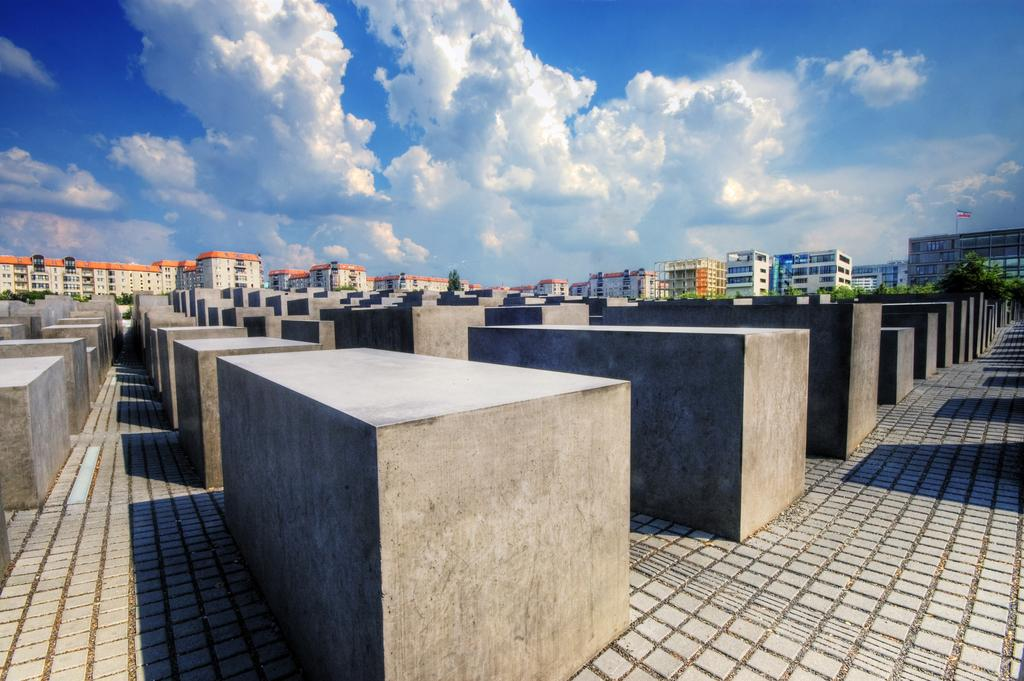What can be found in the center of the image on the floor? There are pillars on the floor in the center of the image. What is visible in the background of the image? There are buildings and trees in the background of the image. What can be seen flying in the image? There is a flag visible in the image. What is visible in the sky at the top of the image? There are clouds in the sky at the top of the image. Where is the shelf located in the image? There is no shelf present in the image. What type of game is being played in the image? There is no game being played in the image. 